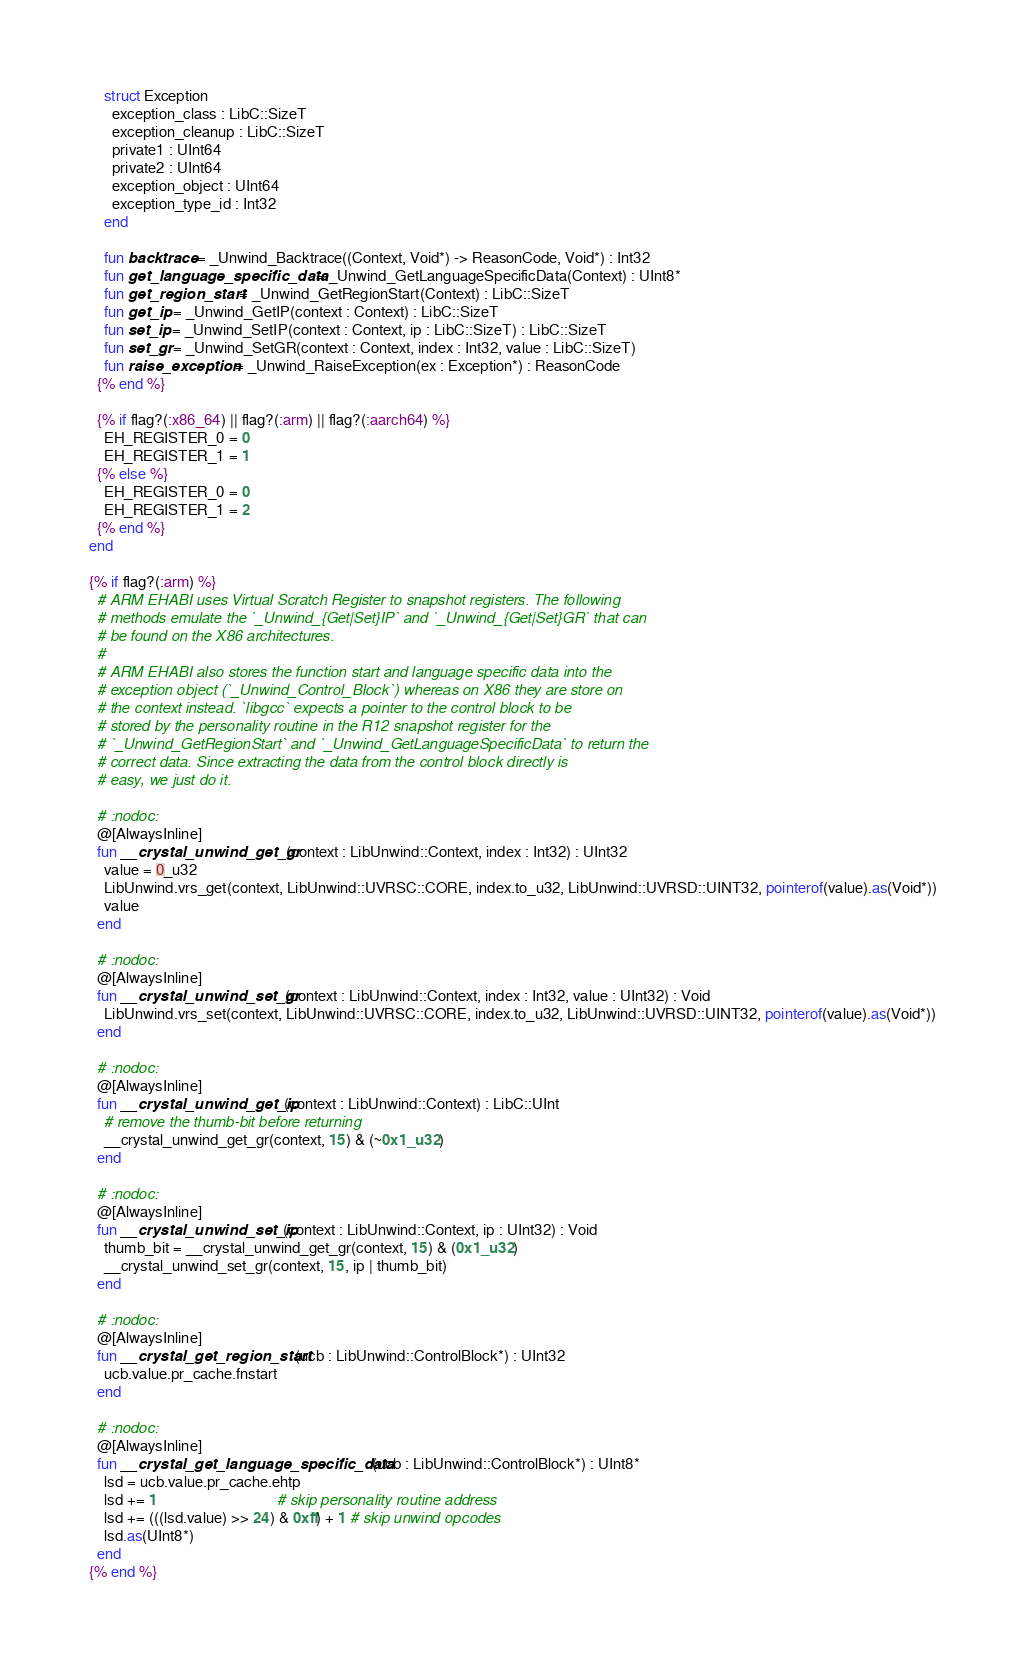Convert code to text. <code><loc_0><loc_0><loc_500><loc_500><_Crystal_>    struct Exception
      exception_class : LibC::SizeT
      exception_cleanup : LibC::SizeT
      private1 : UInt64
      private2 : UInt64
      exception_object : UInt64
      exception_type_id : Int32
    end

    fun backtrace = _Unwind_Backtrace((Context, Void*) -> ReasonCode, Void*) : Int32
    fun get_language_specific_data = _Unwind_GetLanguageSpecificData(Context) : UInt8*
    fun get_region_start = _Unwind_GetRegionStart(Context) : LibC::SizeT
    fun get_ip = _Unwind_GetIP(context : Context) : LibC::SizeT
    fun set_ip = _Unwind_SetIP(context : Context, ip : LibC::SizeT) : LibC::SizeT
    fun set_gr = _Unwind_SetGR(context : Context, index : Int32, value : LibC::SizeT)
    fun raise_exception = _Unwind_RaiseException(ex : Exception*) : ReasonCode
  {% end %}

  {% if flag?(:x86_64) || flag?(:arm) || flag?(:aarch64) %}
    EH_REGISTER_0 = 0
    EH_REGISTER_1 = 1
  {% else %}
    EH_REGISTER_0 = 0
    EH_REGISTER_1 = 2
  {% end %}
end

{% if flag?(:arm) %}
  # ARM EHABI uses Virtual Scratch Register to snapshot registers. The following
  # methods emulate the `_Unwind_{Get|Set}IP` and `_Unwind_{Get|Set}GR` that can
  # be found on the X86 architectures.
  #
  # ARM EHABI also stores the function start and language specific data into the
  # exception object (`_Unwind_Control_Block`) whereas on X86 they are store on
  # the context instead. `libgcc` expects a pointer to the control block to be
  # stored by the personality routine in the R12 snapshot register for the
  # `_Unwind_GetRegionStart` and `_Unwind_GetLanguageSpecificData` to return the
  # correct data. Since extracting the data from the control block directly is
  # easy, we just do it.

  # :nodoc:
  @[AlwaysInline]
  fun __crystal_unwind_get_gr(context : LibUnwind::Context, index : Int32) : UInt32
    value = 0_u32
    LibUnwind.vrs_get(context, LibUnwind::UVRSC::CORE, index.to_u32, LibUnwind::UVRSD::UINT32, pointerof(value).as(Void*))
    value
  end

  # :nodoc:
  @[AlwaysInline]
  fun __crystal_unwind_set_gr(context : LibUnwind::Context, index : Int32, value : UInt32) : Void
    LibUnwind.vrs_set(context, LibUnwind::UVRSC::CORE, index.to_u32, LibUnwind::UVRSD::UINT32, pointerof(value).as(Void*))
  end

  # :nodoc:
  @[AlwaysInline]
  fun __crystal_unwind_get_ip(context : LibUnwind::Context) : LibC::UInt
    # remove the thumb-bit before returning
    __crystal_unwind_get_gr(context, 15) & (~0x1_u32)
  end

  # :nodoc:
  @[AlwaysInline]
  fun __crystal_unwind_set_ip(context : LibUnwind::Context, ip : UInt32) : Void
    thumb_bit = __crystal_unwind_get_gr(context, 15) & (0x1_u32)
    __crystal_unwind_set_gr(context, 15, ip | thumb_bit)
  end

  # :nodoc:
  @[AlwaysInline]
  fun __crystal_get_region_start(ucb : LibUnwind::ControlBlock*) : UInt32
    ucb.value.pr_cache.fnstart
  end

  # :nodoc:
  @[AlwaysInline]
  fun __crystal_get_language_specific_data(ucb : LibUnwind::ControlBlock*) : UInt8*
    lsd = ucb.value.pr_cache.ehtp
    lsd += 1                                # skip personality routine address
    lsd += (((lsd.value) >> 24) & 0xff) + 1 # skip unwind opcodes
    lsd.as(UInt8*)
  end
{% end %}
</code> 